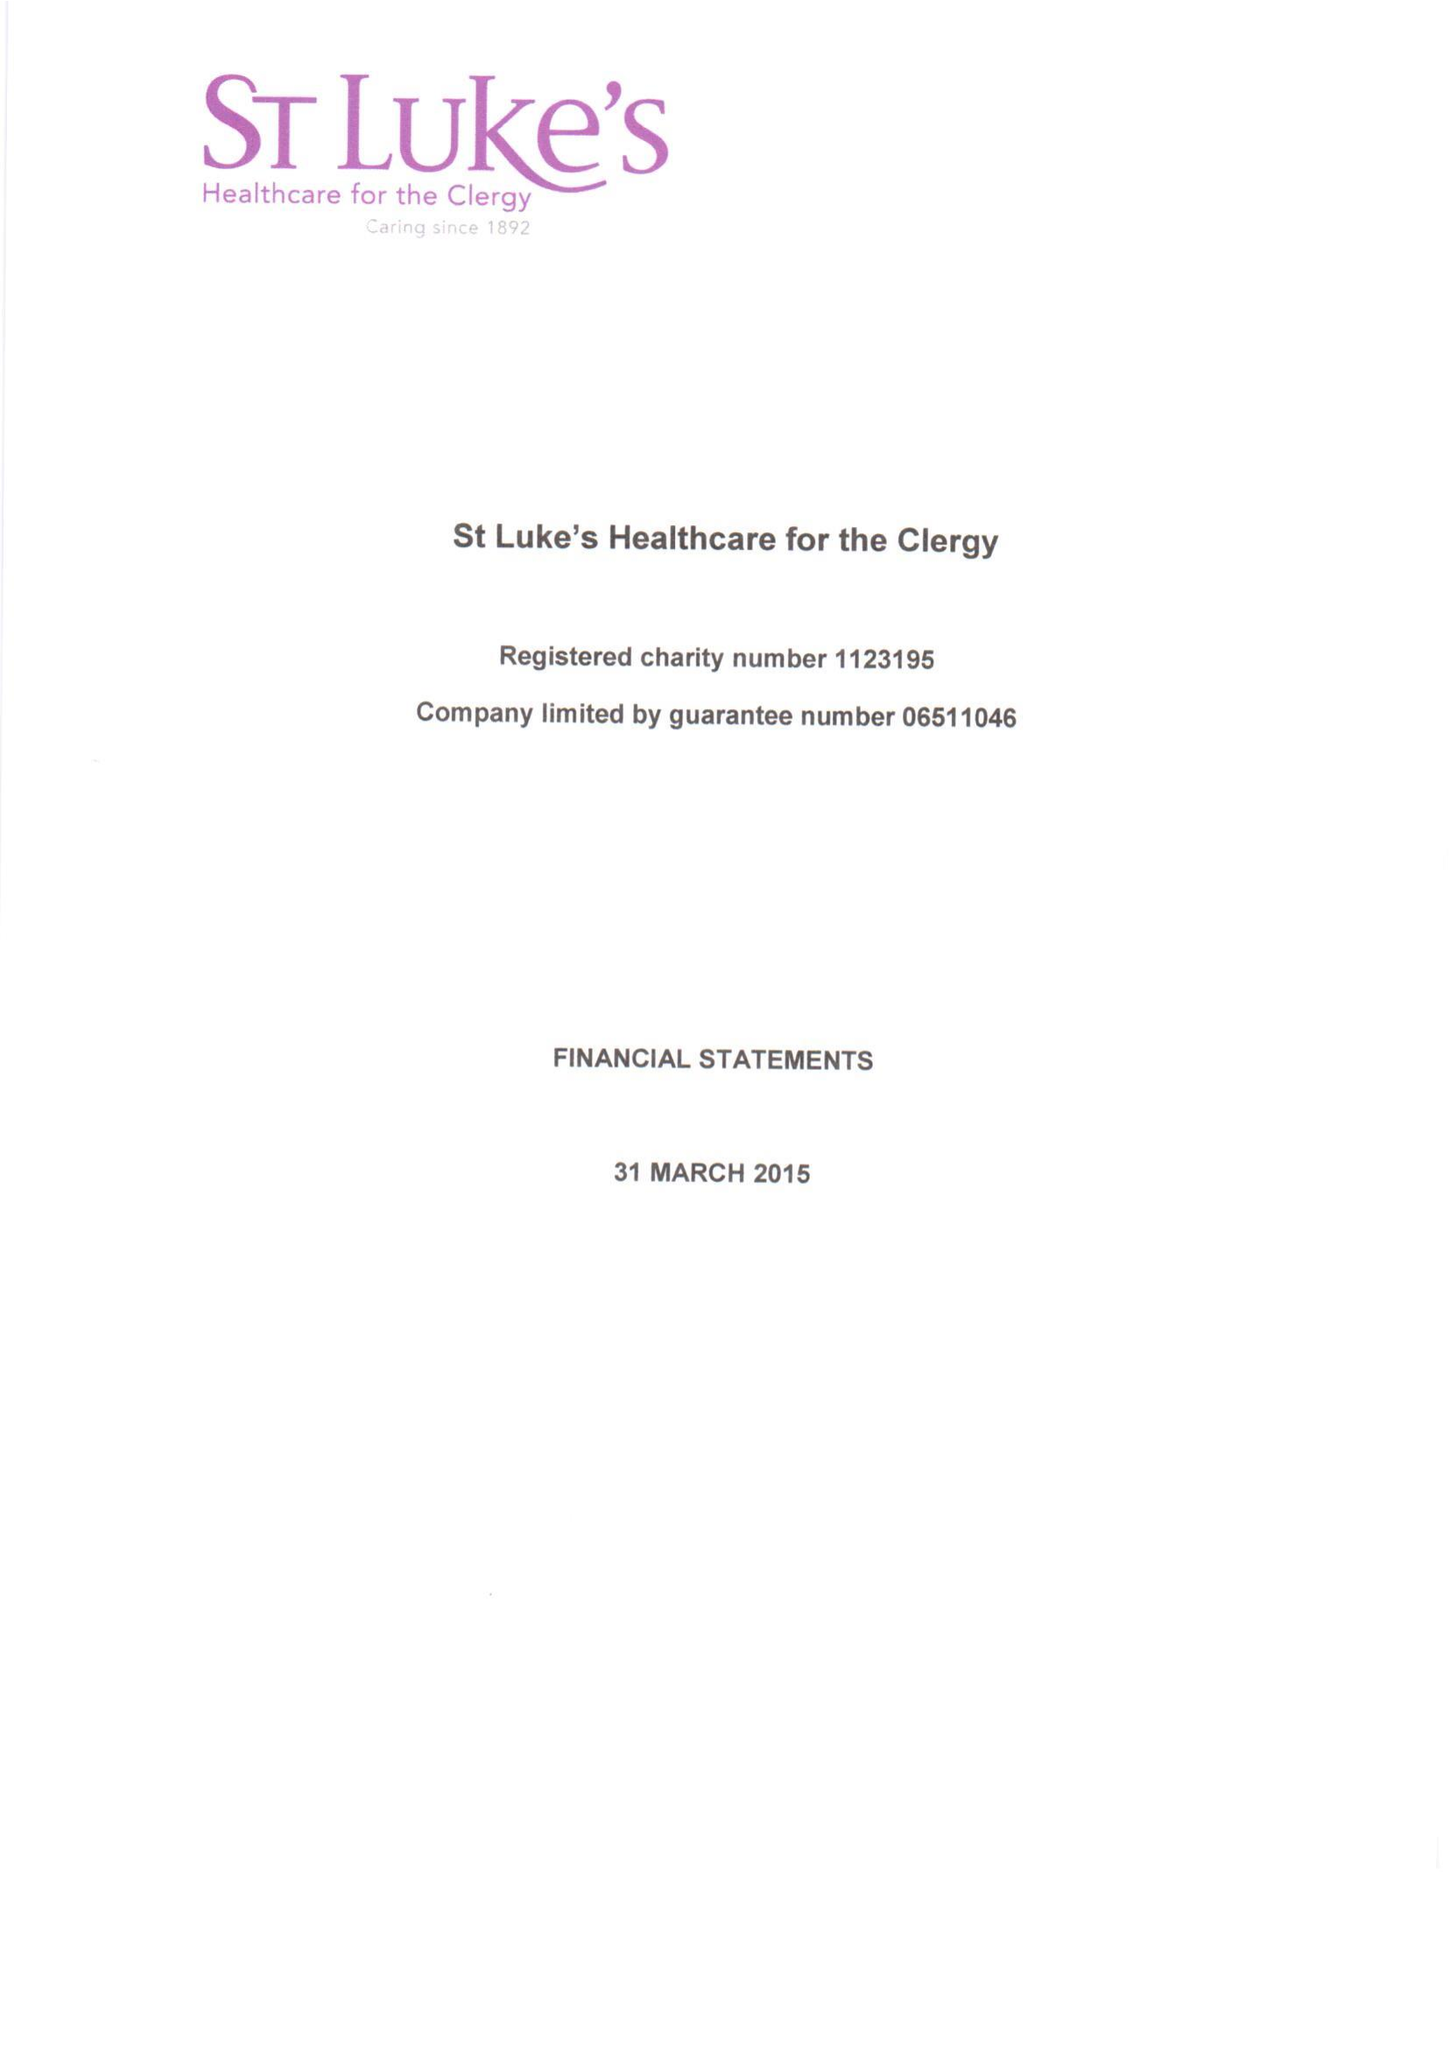What is the value for the income_annually_in_british_pounds?
Answer the question using a single word or phrase. 255256.00 